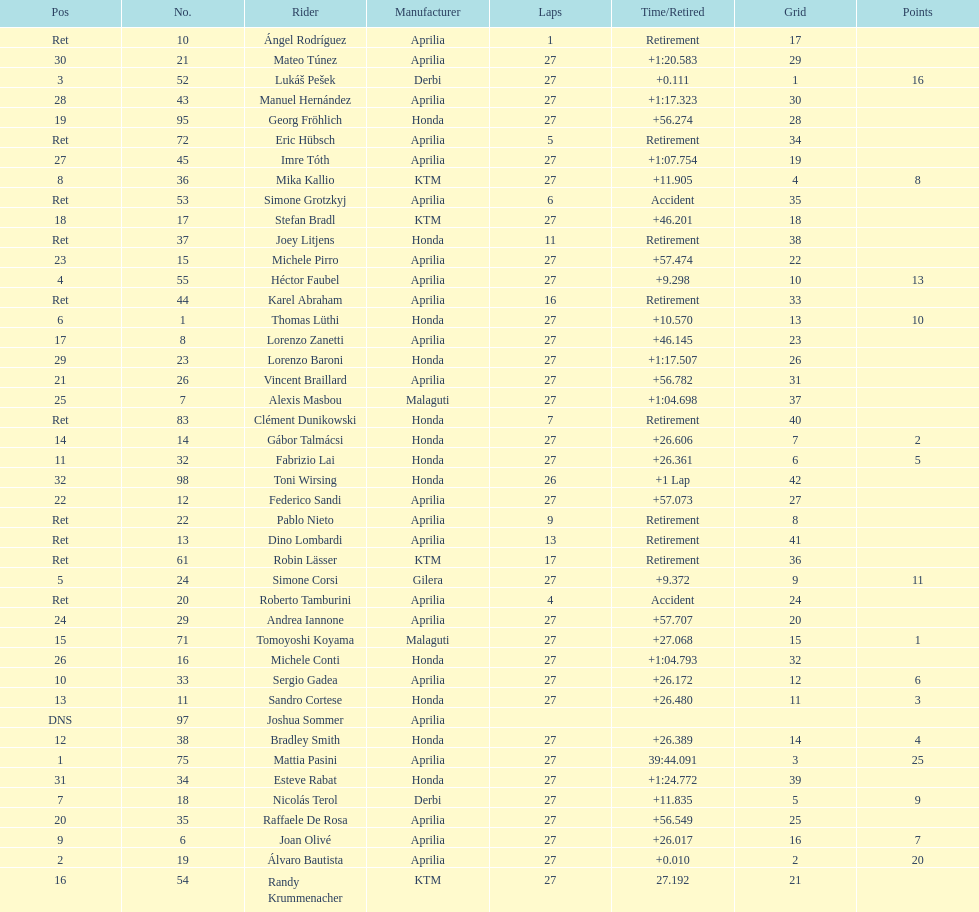What was the total number of positions in the 125cc classification? 43. 